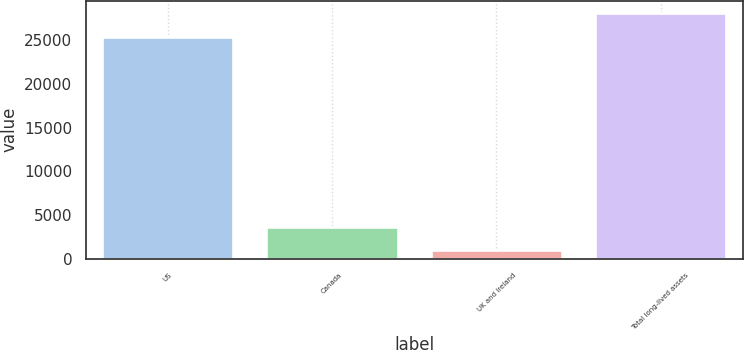Convert chart. <chart><loc_0><loc_0><loc_500><loc_500><bar_chart><fcel>US<fcel>Canada<fcel>UK and Ireland<fcel>Total long-lived assets<nl><fcel>25359<fcel>3684.5<fcel>967<fcel>28142<nl></chart> 